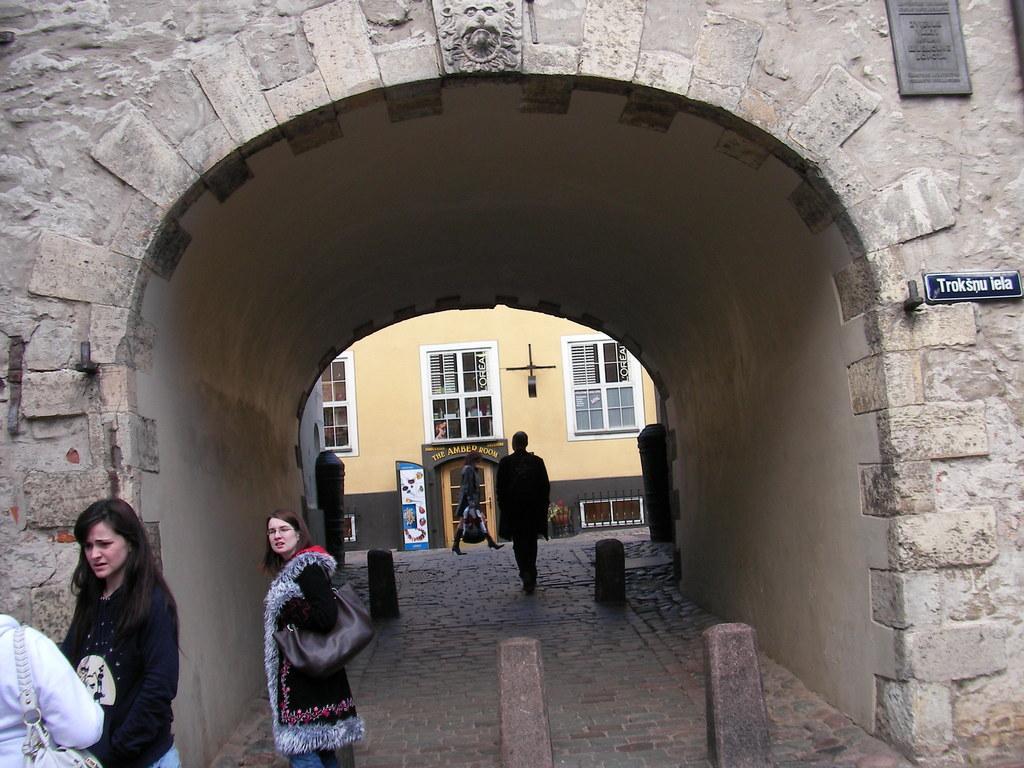Can you describe this image briefly? In this image there are people on the left corner. There is floor at the bottom. There are people and it looks like an entrance in the foreground. There are people and a building with doors and text in the background. There is text and a frame on the right corner. 